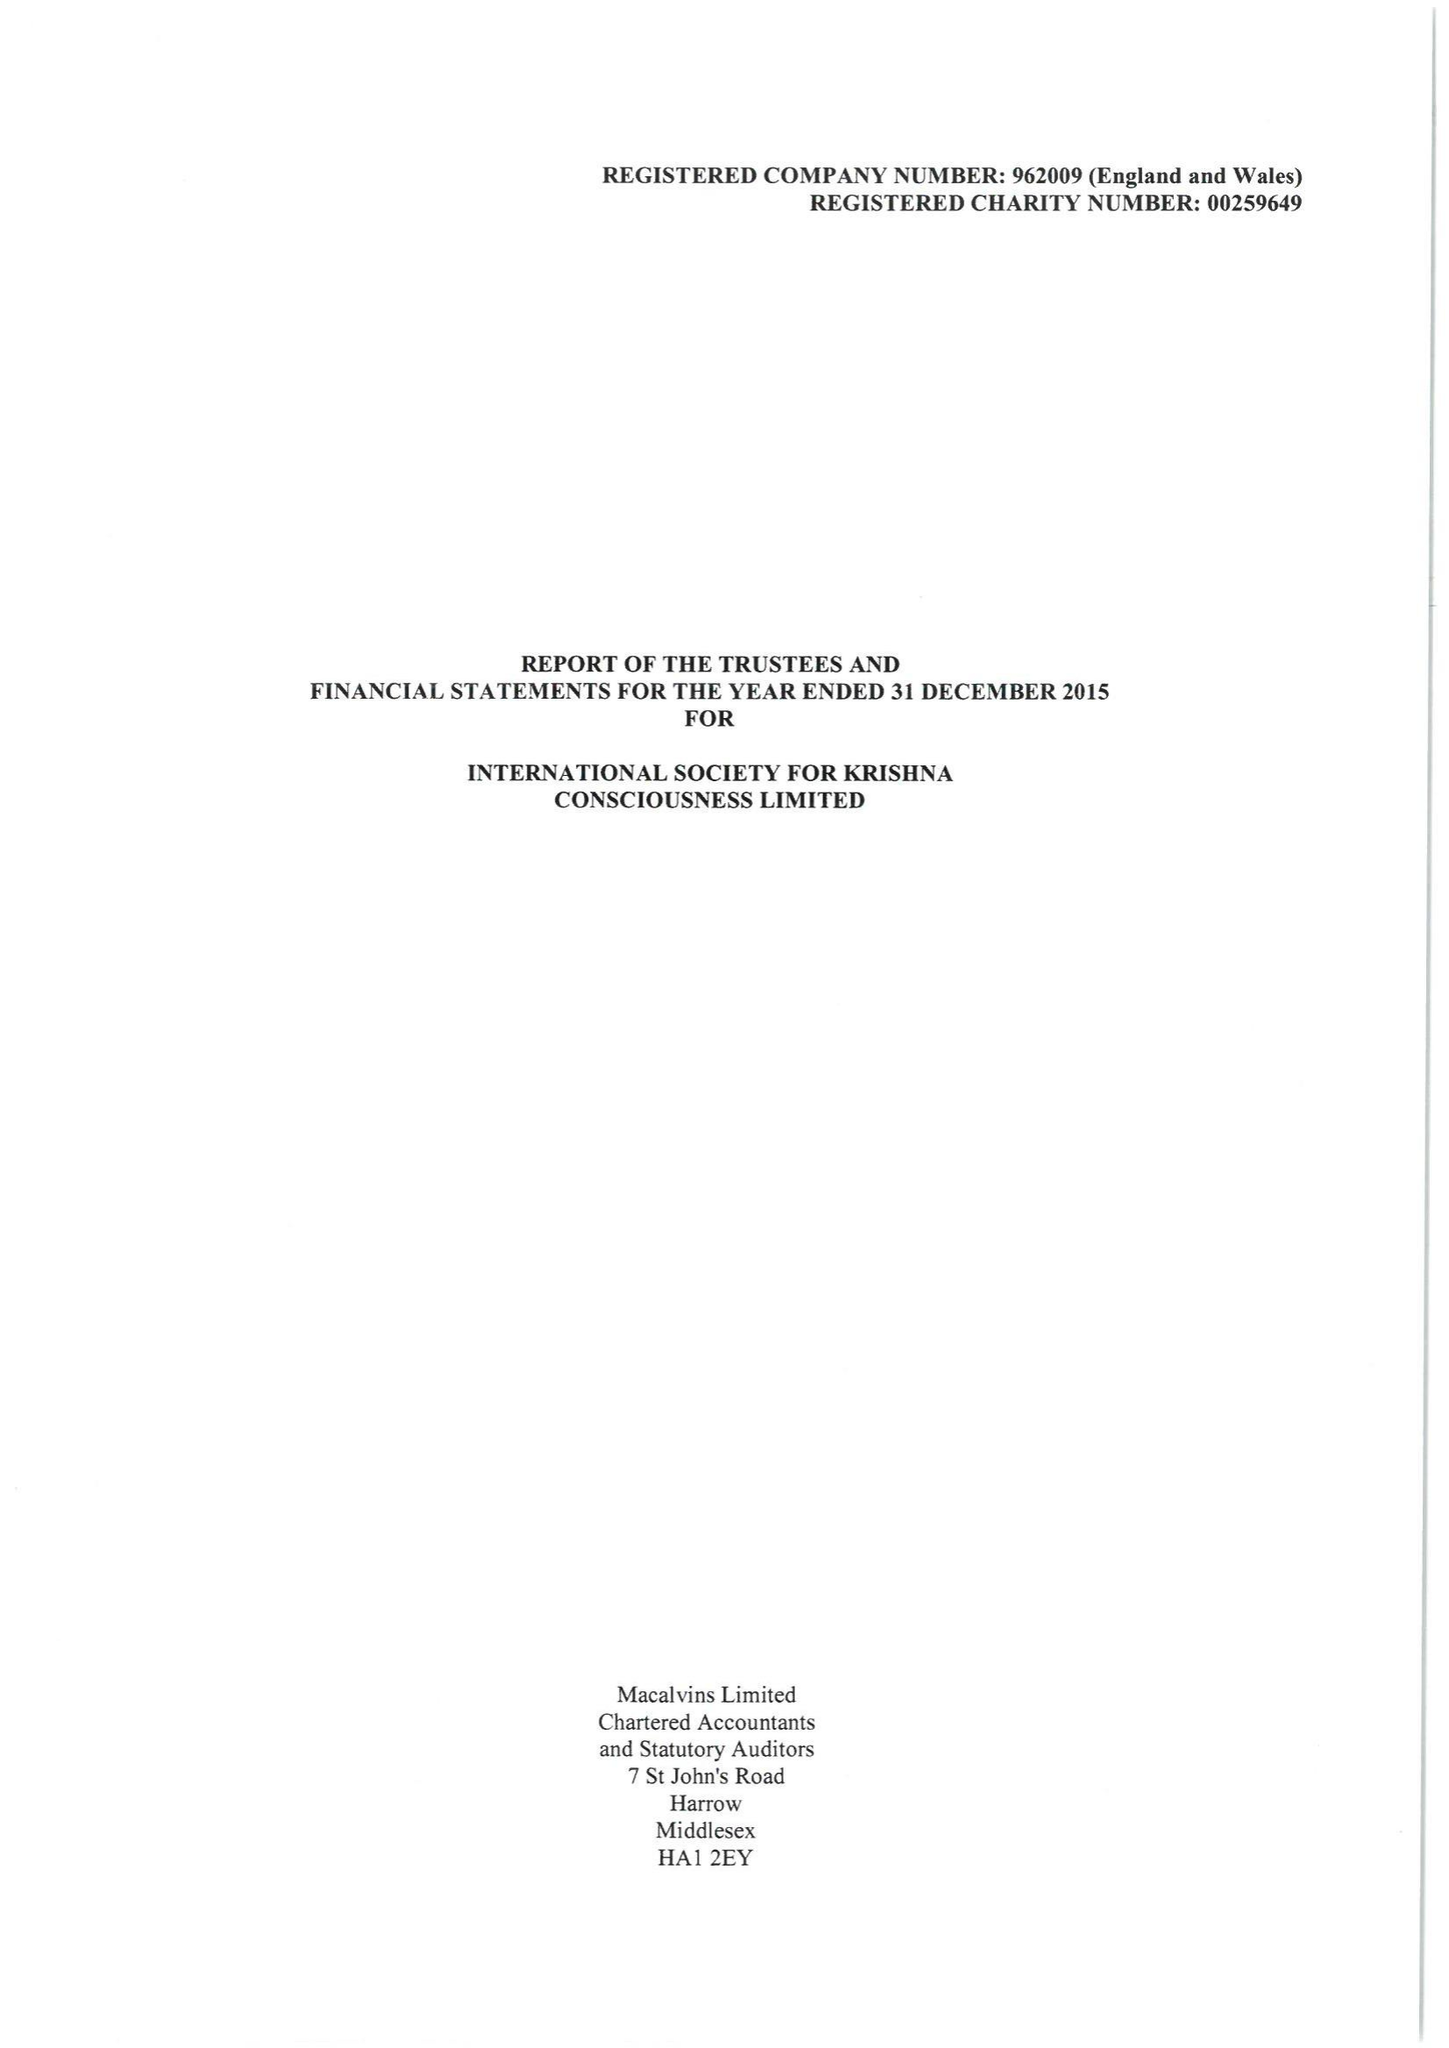What is the value for the address__postcode?
Answer the question using a single word or phrase. WD7 8LA 